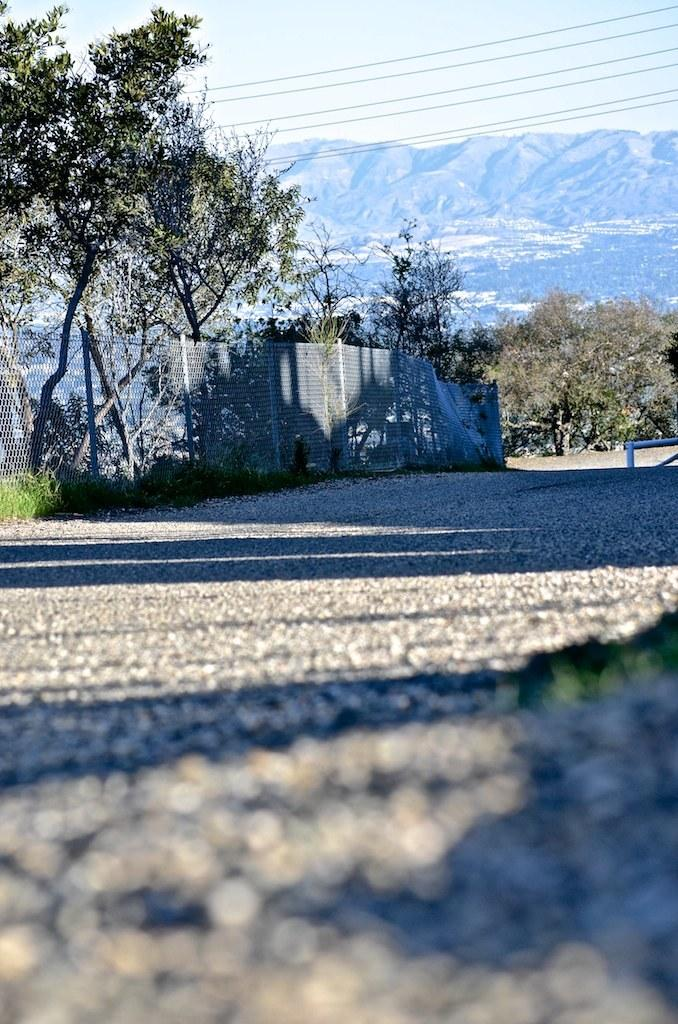What type of pathway is present in the image? There is a road in the image. What structure can be seen alongside the road? There is a fence in the image. What type of vegetation is present in the image? There are trees in the image. What can be seen in the distance in the image? There are hills visible in the background of the image. What is visible above the hills in the image? The sky is visible in the background of the image. Can you tell me how many volleyballs are lying on the road in the image? There are no volleyballs present in the image; it features a road, a fence, trees, hills, and the sky. What type of coil is wrapped around the trees in the image? There is no coil present in the image; it features a road, a fence, trees, hills, and the sky. 